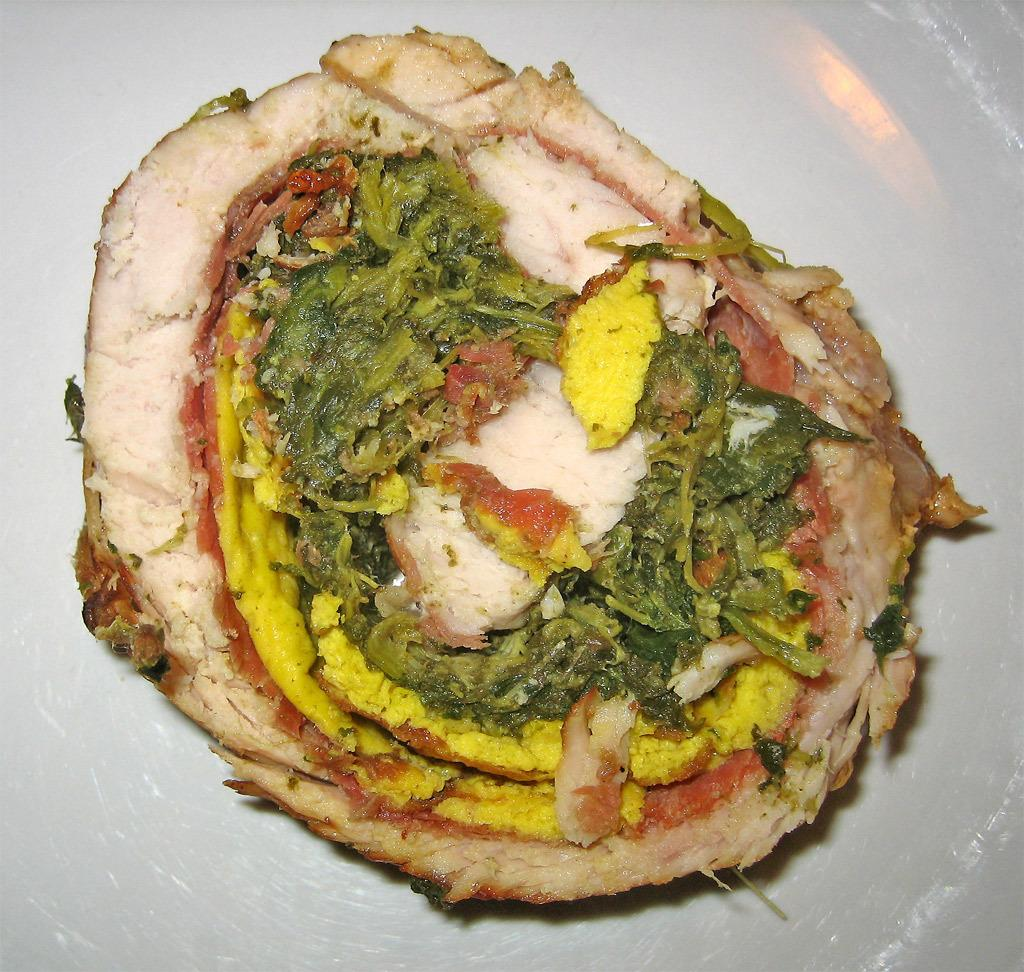What type of object can be seen in the image? There is an edible object in the image. What color is the background in the image? The background is white in color. What might the white background be? The white background might be a plate or a tray. What type of bubble can be seen in the image? There is no bubble present in the image. What is the position of the rail in the image? There is no rail present in the image. 